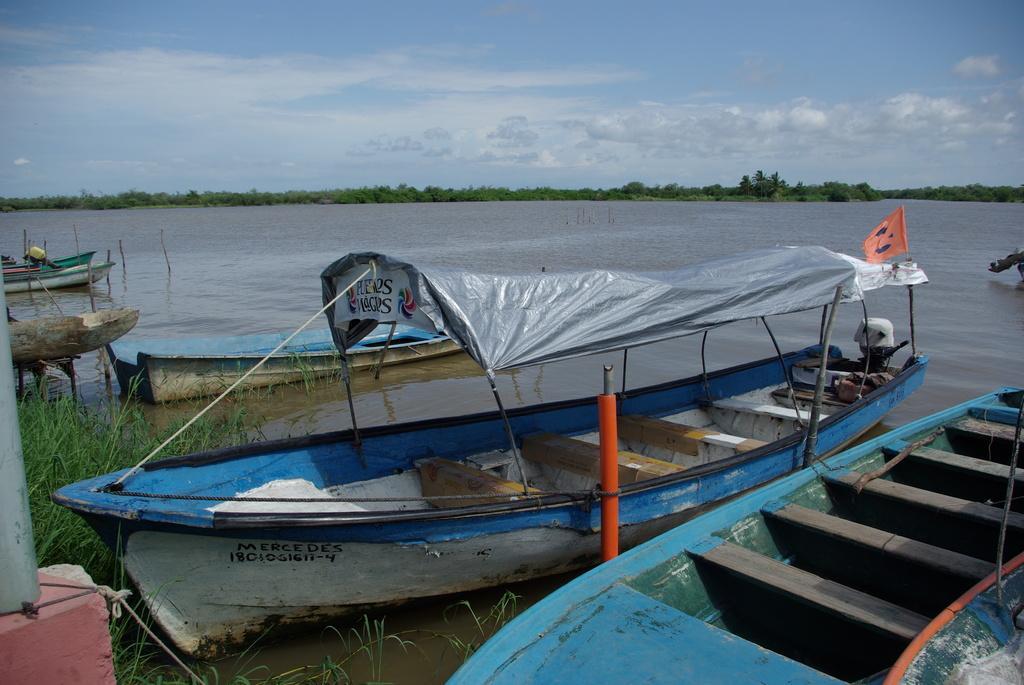How would you summarize this image in a sentence or two? In this image we can see the boats on the surface of the water. We can also see the flag, trees, grass, ropes and also the rods. Sky is also visible with the clouds. 